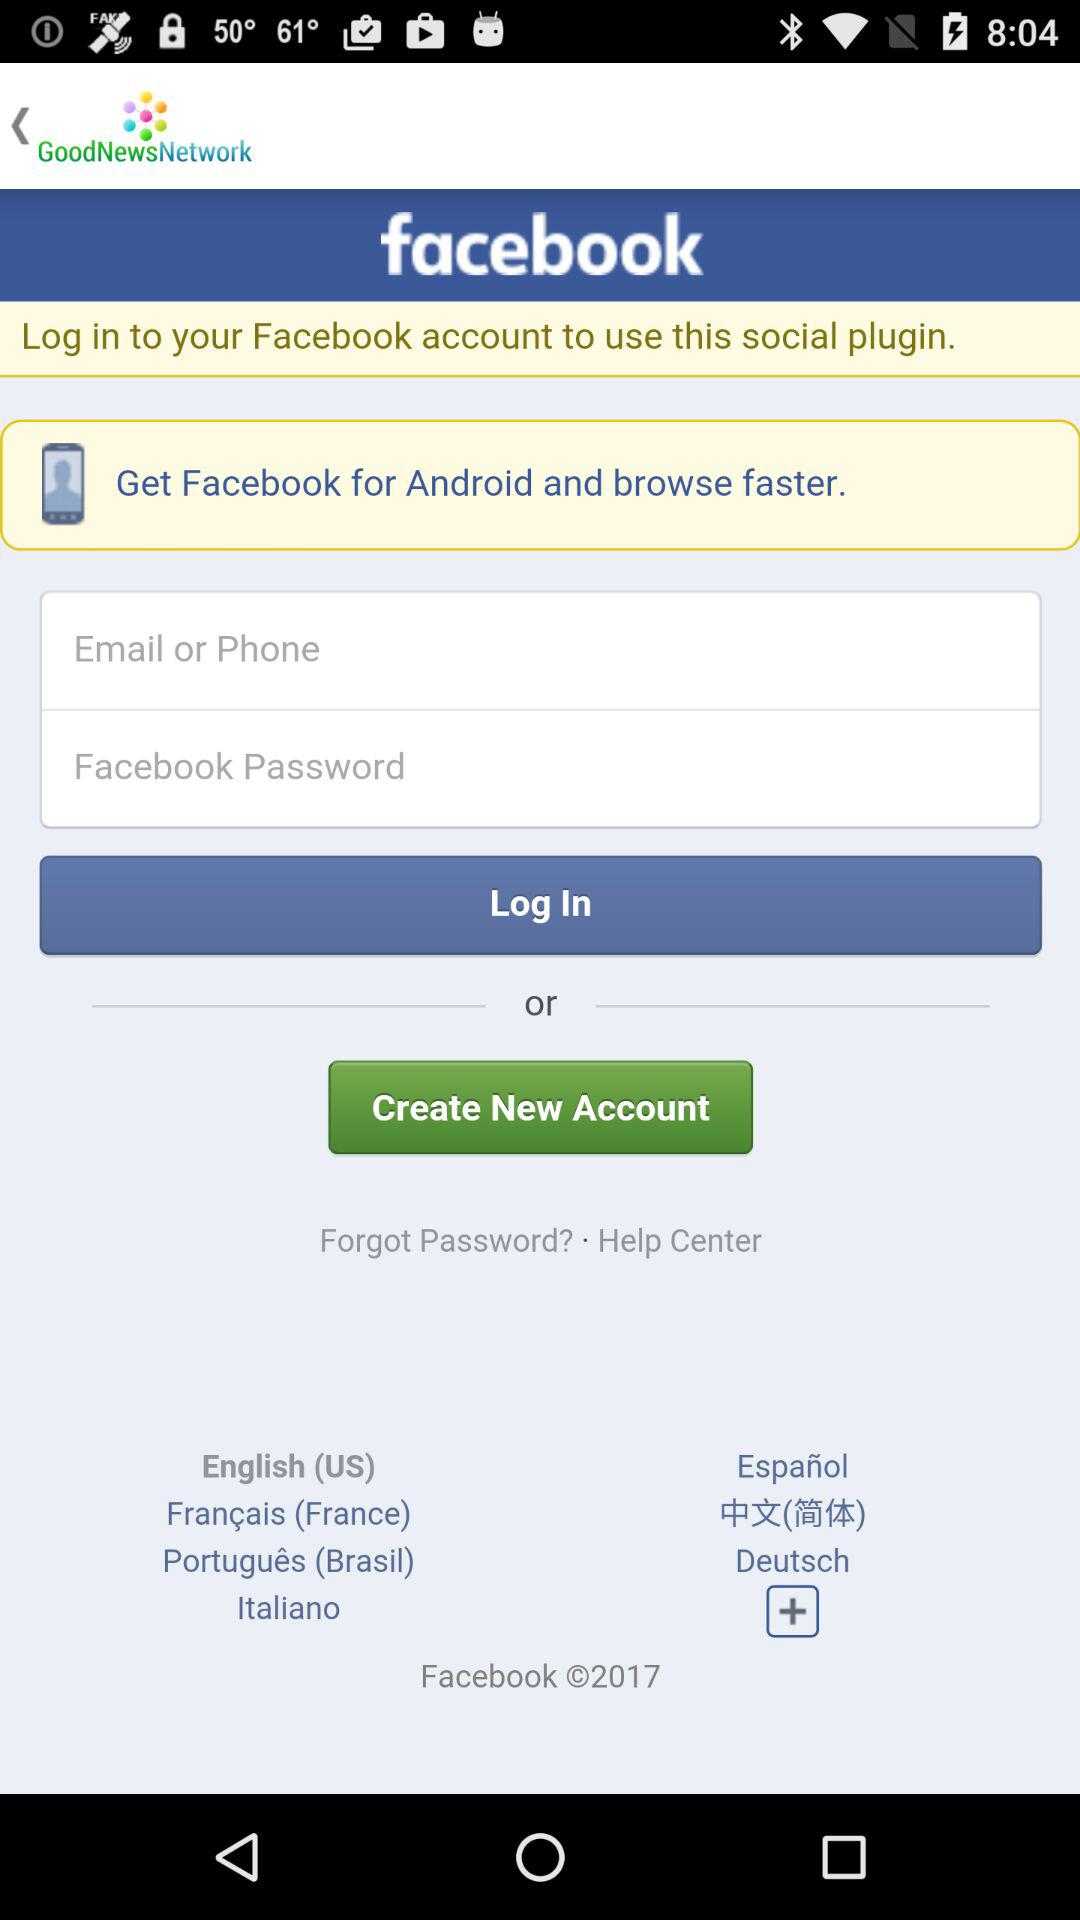What application can be used to log in? The application that can be used to log in is "facebook". 